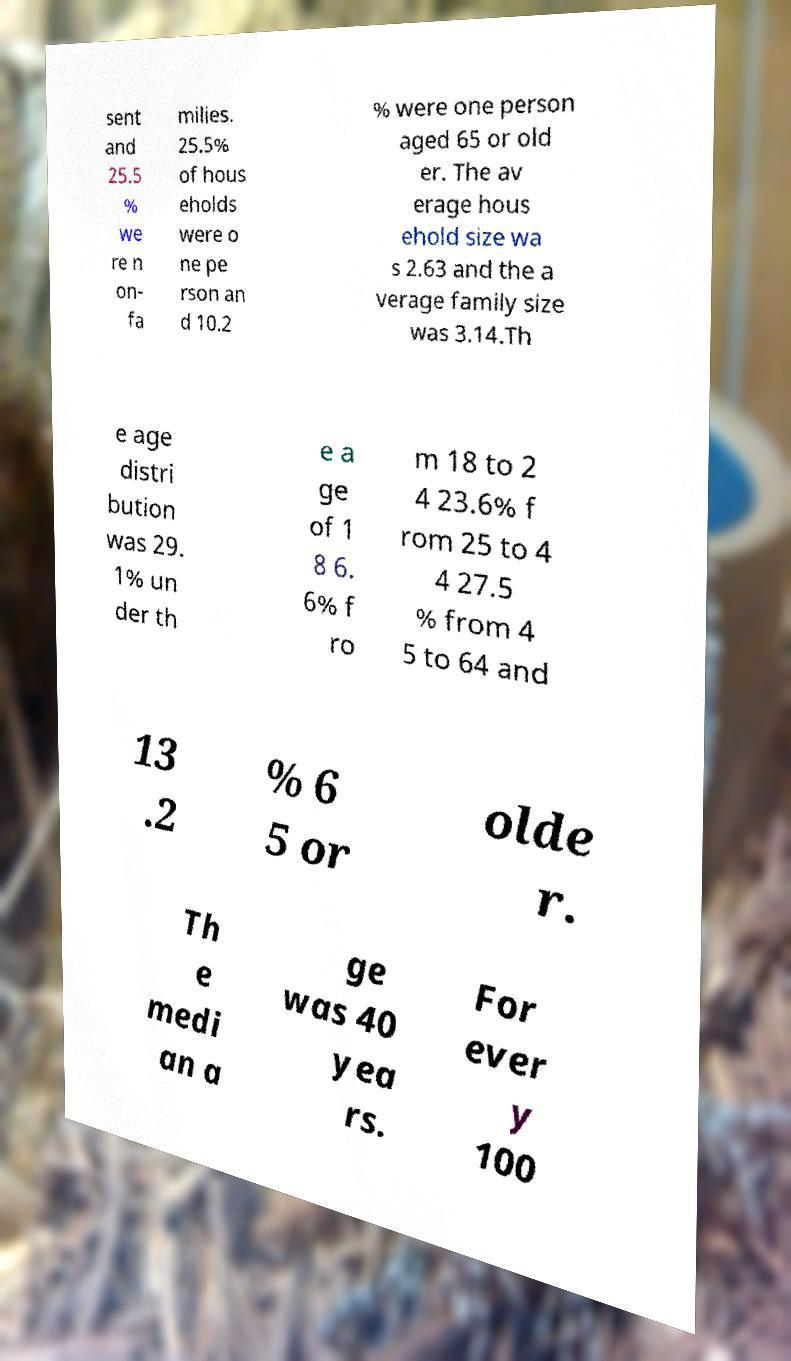For documentation purposes, I need the text within this image transcribed. Could you provide that? sent and 25.5 % we re n on- fa milies. 25.5% of hous eholds were o ne pe rson an d 10.2 % were one person aged 65 or old er. The av erage hous ehold size wa s 2.63 and the a verage family size was 3.14.Th e age distri bution was 29. 1% un der th e a ge of 1 8 6. 6% f ro m 18 to 2 4 23.6% f rom 25 to 4 4 27.5 % from 4 5 to 64 and 13 .2 % 6 5 or olde r. Th e medi an a ge was 40 yea rs. For ever y 100 